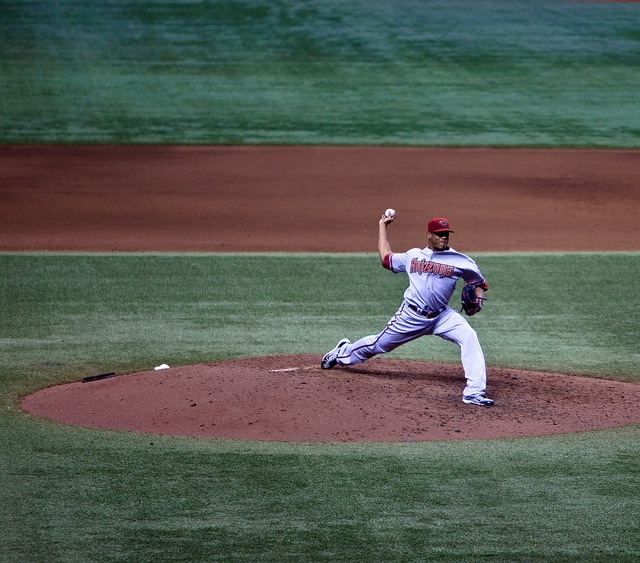Describe the objects in this image and their specific colors. I can see people in black, lavender, lightblue, and blue tones, baseball glove in black, navy, gray, and purple tones, and sports ball in black, lavender, darkgray, and purple tones in this image. 